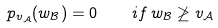<formula> <loc_0><loc_0><loc_500><loc_500>p _ { v _ { \mathcal { A } } } ( w _ { \mathcal { B } } ) = 0 \quad i f \, w _ { \mathcal { B } } \not \geq v _ { \mathcal { A } }</formula> 